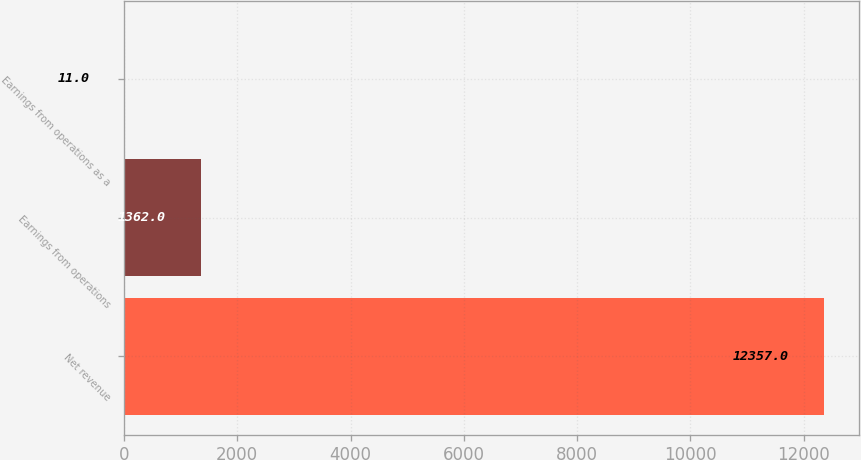Convert chart to OTSL. <chart><loc_0><loc_0><loc_500><loc_500><bar_chart><fcel>Net revenue<fcel>Earnings from operations<fcel>Earnings from operations as a<nl><fcel>12357<fcel>1362<fcel>11<nl></chart> 